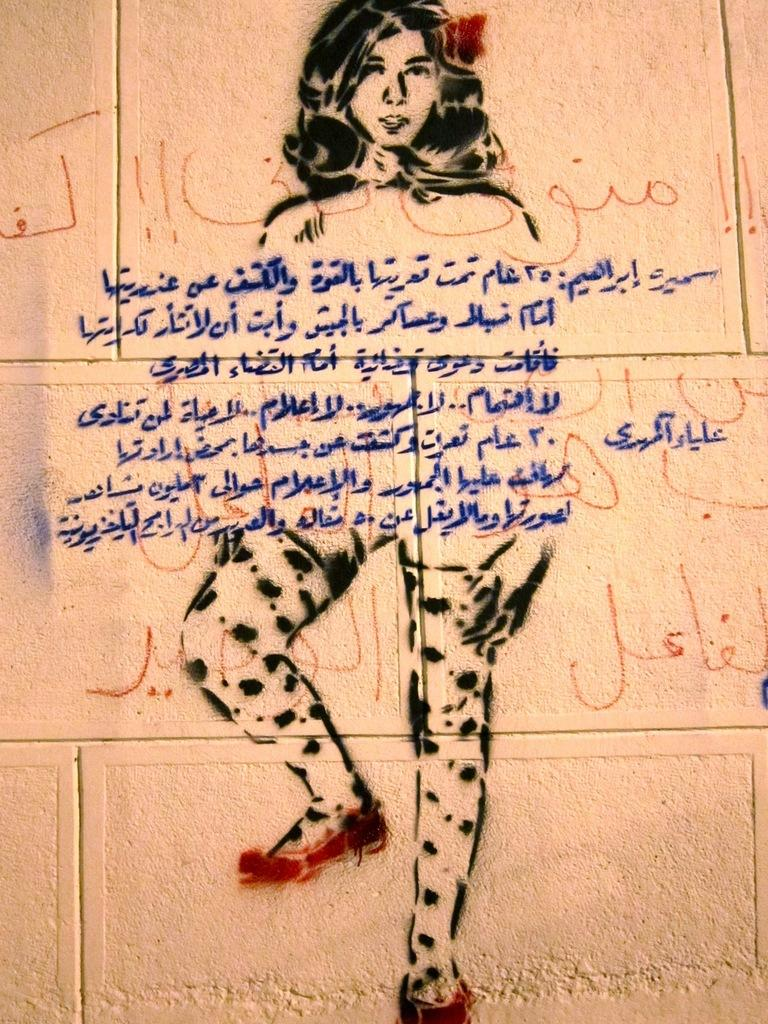What is the main subject of the painting in the image? The main subject of the painting in the image is a woman. Can you describe anything else in the image besides the painting? Yes, there is something written on a wall in the image. What type of cracker is being used to clean the woman's eye in the image? There is no cracker or cleaning activity involving the woman's eye in the image. 